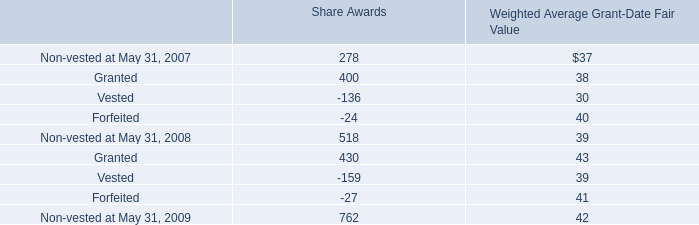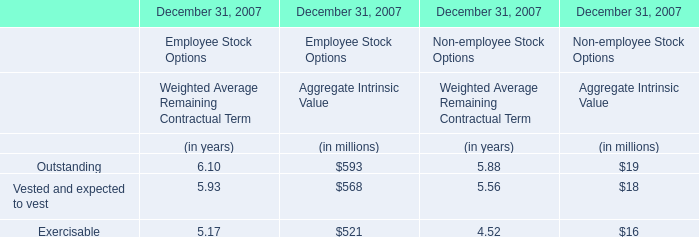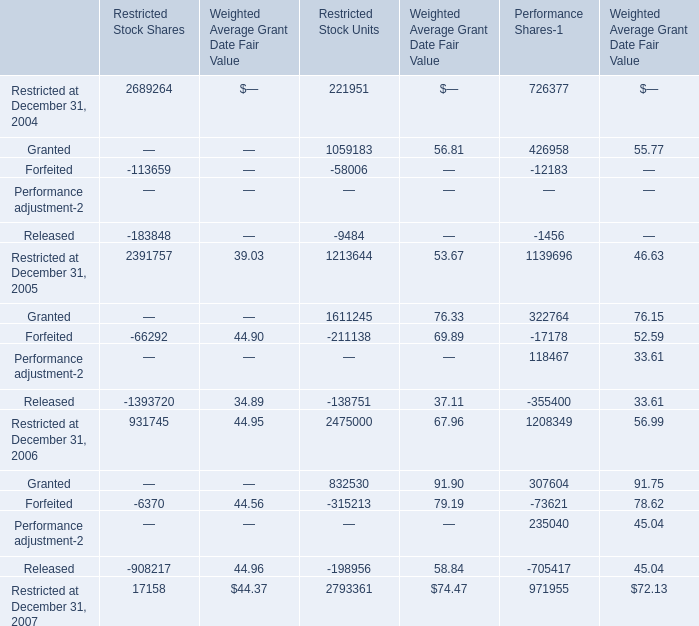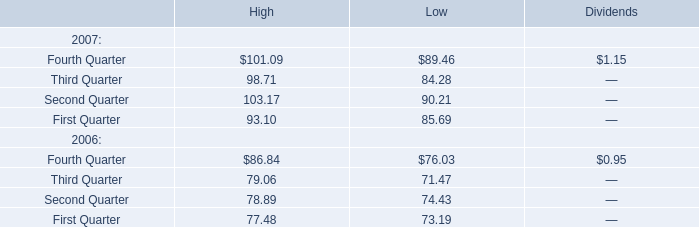what is an employees total annual compensation? 
Computations: (25000 / 20%)
Answer: 125000.0. 